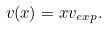<formula> <loc_0><loc_0><loc_500><loc_500>v ( x ) = x v _ { e x p } .</formula> 